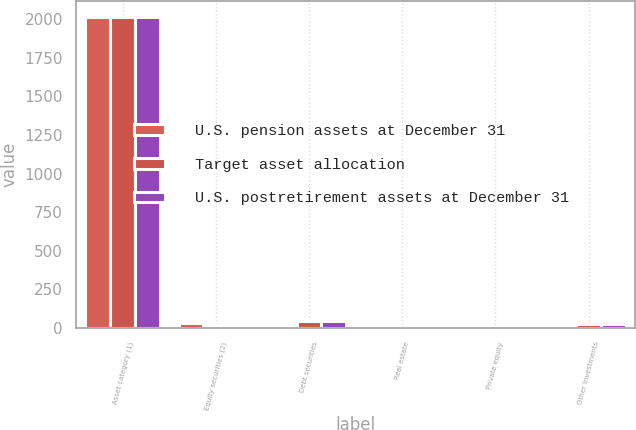Convert chart to OTSL. <chart><loc_0><loc_0><loc_500><loc_500><stacked_bar_chart><ecel><fcel>Asset category (1)<fcel>Equity securities (2)<fcel>Debt securities<fcel>Real estate<fcel>Private equity<fcel>Other investments<nl><fcel>U.S. pension assets at December 31<fcel>2016<fcel>30<fcel>22<fcel>7<fcel>10<fcel>22<nl><fcel>Target asset allocation<fcel>2015<fcel>19<fcel>46<fcel>4<fcel>6<fcel>25<nl><fcel>U.S. postretirement assets at December 31<fcel>2015<fcel>19<fcel>46<fcel>4<fcel>6<fcel>25<nl></chart> 